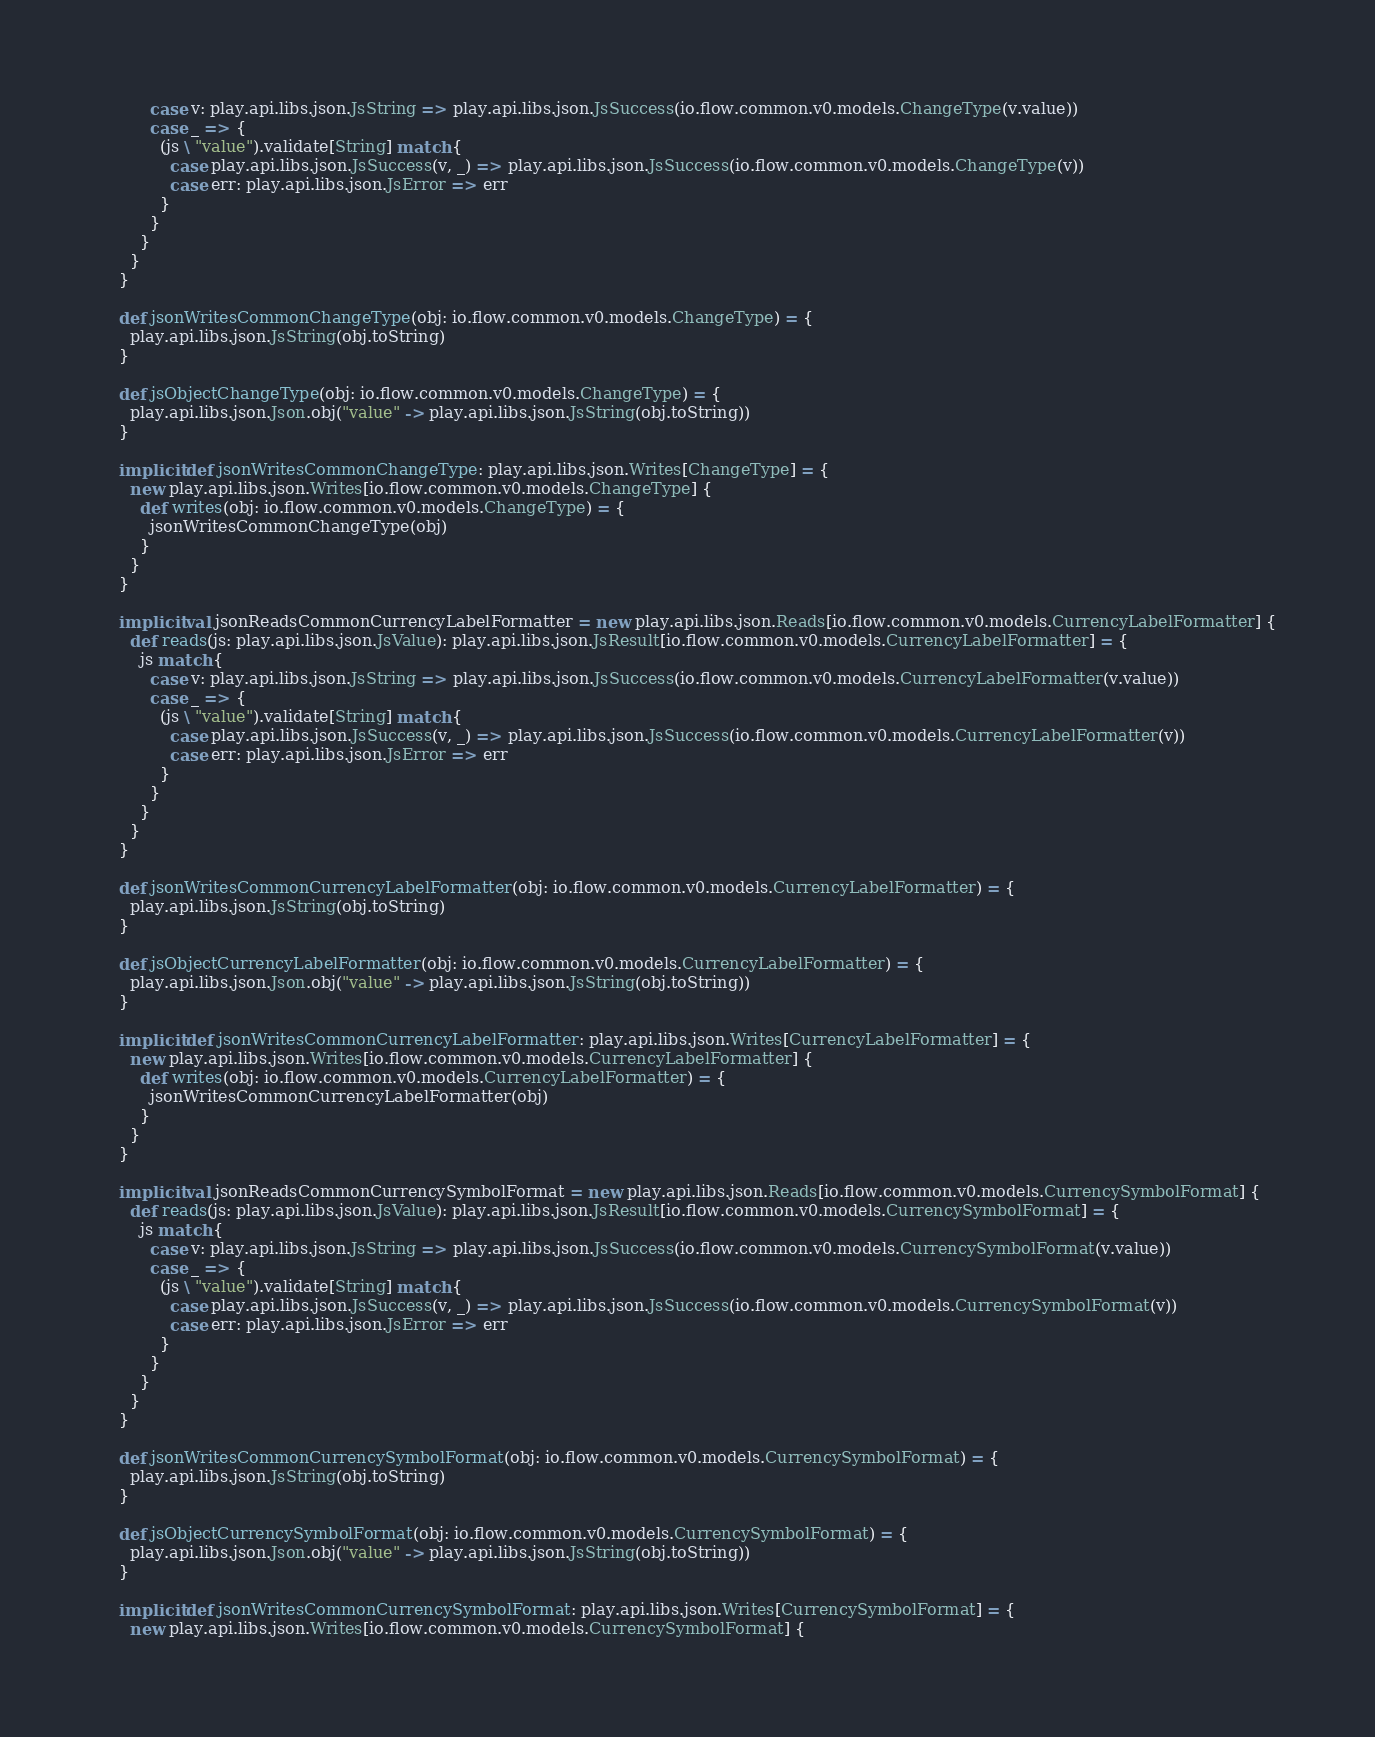Convert code to text. <code><loc_0><loc_0><loc_500><loc_500><_Scala_>          case v: play.api.libs.json.JsString => play.api.libs.json.JsSuccess(io.flow.common.v0.models.ChangeType(v.value))
          case _ => {
            (js \ "value").validate[String] match {
              case play.api.libs.json.JsSuccess(v, _) => play.api.libs.json.JsSuccess(io.flow.common.v0.models.ChangeType(v))
              case err: play.api.libs.json.JsError => err
            }
          }
        }
      }
    }

    def jsonWritesCommonChangeType(obj: io.flow.common.v0.models.ChangeType) = {
      play.api.libs.json.JsString(obj.toString)
    }

    def jsObjectChangeType(obj: io.flow.common.v0.models.ChangeType) = {
      play.api.libs.json.Json.obj("value" -> play.api.libs.json.JsString(obj.toString))
    }

    implicit def jsonWritesCommonChangeType: play.api.libs.json.Writes[ChangeType] = {
      new play.api.libs.json.Writes[io.flow.common.v0.models.ChangeType] {
        def writes(obj: io.flow.common.v0.models.ChangeType) = {
          jsonWritesCommonChangeType(obj)
        }
      }
    }

    implicit val jsonReadsCommonCurrencyLabelFormatter = new play.api.libs.json.Reads[io.flow.common.v0.models.CurrencyLabelFormatter] {
      def reads(js: play.api.libs.json.JsValue): play.api.libs.json.JsResult[io.flow.common.v0.models.CurrencyLabelFormatter] = {
        js match {
          case v: play.api.libs.json.JsString => play.api.libs.json.JsSuccess(io.flow.common.v0.models.CurrencyLabelFormatter(v.value))
          case _ => {
            (js \ "value").validate[String] match {
              case play.api.libs.json.JsSuccess(v, _) => play.api.libs.json.JsSuccess(io.flow.common.v0.models.CurrencyLabelFormatter(v))
              case err: play.api.libs.json.JsError => err
            }
          }
        }
      }
    }

    def jsonWritesCommonCurrencyLabelFormatter(obj: io.flow.common.v0.models.CurrencyLabelFormatter) = {
      play.api.libs.json.JsString(obj.toString)
    }

    def jsObjectCurrencyLabelFormatter(obj: io.flow.common.v0.models.CurrencyLabelFormatter) = {
      play.api.libs.json.Json.obj("value" -> play.api.libs.json.JsString(obj.toString))
    }

    implicit def jsonWritesCommonCurrencyLabelFormatter: play.api.libs.json.Writes[CurrencyLabelFormatter] = {
      new play.api.libs.json.Writes[io.flow.common.v0.models.CurrencyLabelFormatter] {
        def writes(obj: io.flow.common.v0.models.CurrencyLabelFormatter) = {
          jsonWritesCommonCurrencyLabelFormatter(obj)
        }
      }
    }

    implicit val jsonReadsCommonCurrencySymbolFormat = new play.api.libs.json.Reads[io.flow.common.v0.models.CurrencySymbolFormat] {
      def reads(js: play.api.libs.json.JsValue): play.api.libs.json.JsResult[io.flow.common.v0.models.CurrencySymbolFormat] = {
        js match {
          case v: play.api.libs.json.JsString => play.api.libs.json.JsSuccess(io.flow.common.v0.models.CurrencySymbolFormat(v.value))
          case _ => {
            (js \ "value").validate[String] match {
              case play.api.libs.json.JsSuccess(v, _) => play.api.libs.json.JsSuccess(io.flow.common.v0.models.CurrencySymbolFormat(v))
              case err: play.api.libs.json.JsError => err
            }
          }
        }
      }
    }

    def jsonWritesCommonCurrencySymbolFormat(obj: io.flow.common.v0.models.CurrencySymbolFormat) = {
      play.api.libs.json.JsString(obj.toString)
    }

    def jsObjectCurrencySymbolFormat(obj: io.flow.common.v0.models.CurrencySymbolFormat) = {
      play.api.libs.json.Json.obj("value" -> play.api.libs.json.JsString(obj.toString))
    }

    implicit def jsonWritesCommonCurrencySymbolFormat: play.api.libs.json.Writes[CurrencySymbolFormat] = {
      new play.api.libs.json.Writes[io.flow.common.v0.models.CurrencySymbolFormat] {</code> 